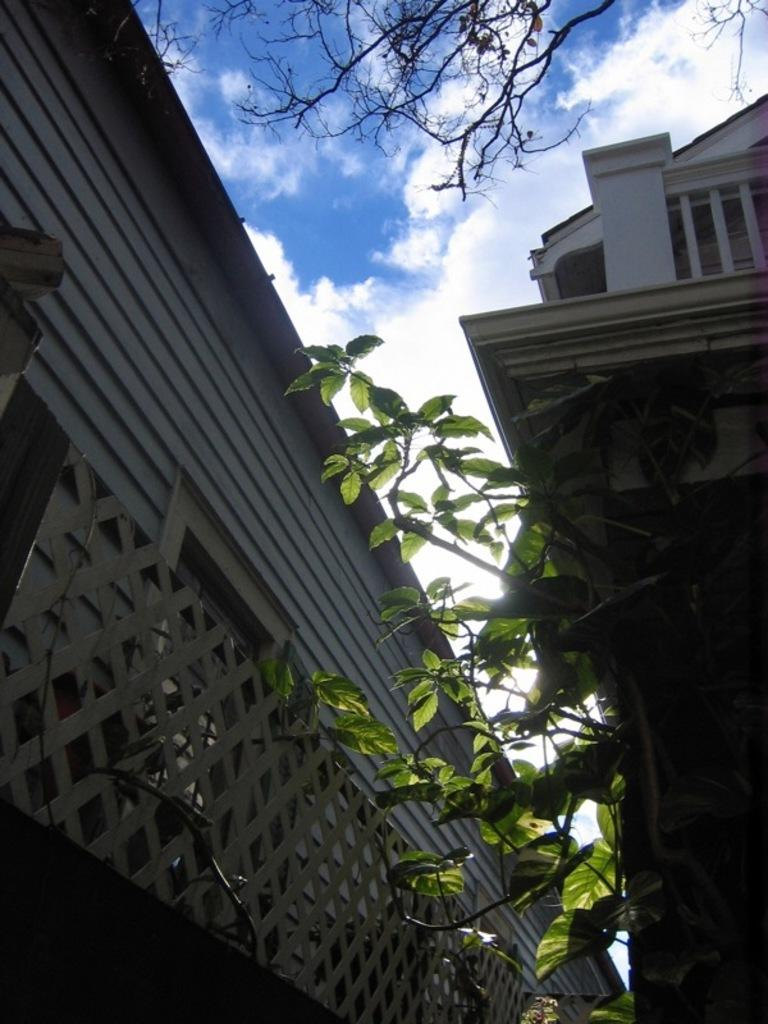What type of structures can be seen in the image? There are buildings in the image. What other natural elements are present in the image? There are trees in the image. What is visible in the sky in the image? There are clouds in the image. What type of quartz can be seen in the image? There is no quartz present in the image. How does the town in the image affect the mind of the viewer? There is no town mentioned in the image, and therefore its effect on the mind of the viewer cannot be determined. 